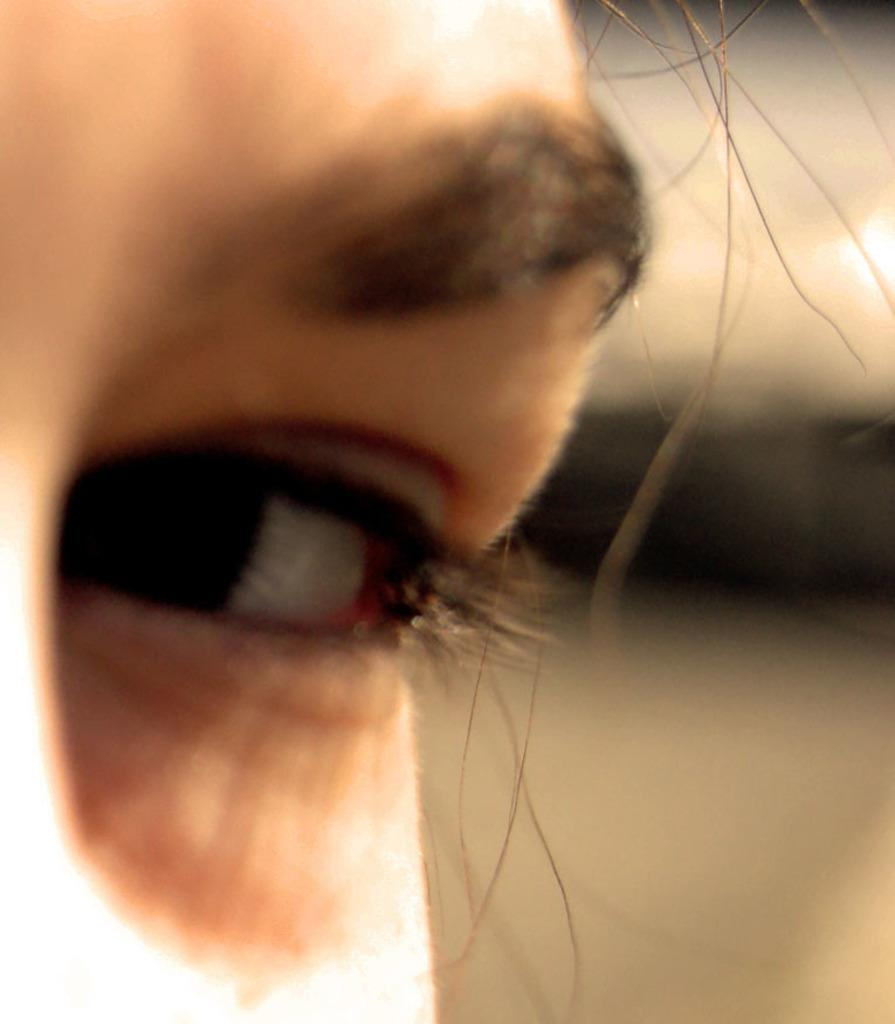What is the main subject of the image? There is a human face in the image. Which facial features are visible in the image? The eyes and eyebrows are visible in the image. How would you describe the background of the image? The background is blurred. What type of chain can be seen hanging from the person's neck in the image? There is no chain visible in the image; it only features a human face with visible eyes and eyebrows. 